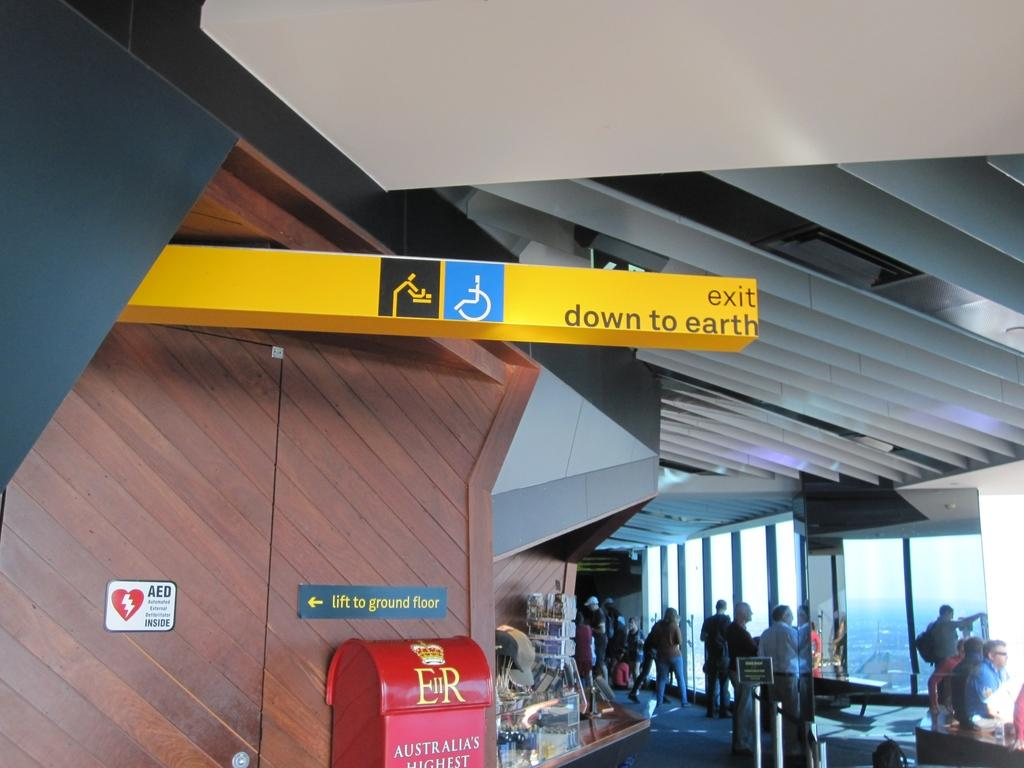What are the persons in the image doing? The persons in the image are standing on the floor. What type of objects can be seen in the image besides the persons? There are sign boards, tables, walls, and glasses visible in the image. What type of cracker is being used to clean the glasses in the image? There is no cracker present in the image, and the glasses are not being cleaned. How much sugar is visible on the tables in the image? There is no sugar visible on the tables in the image. 